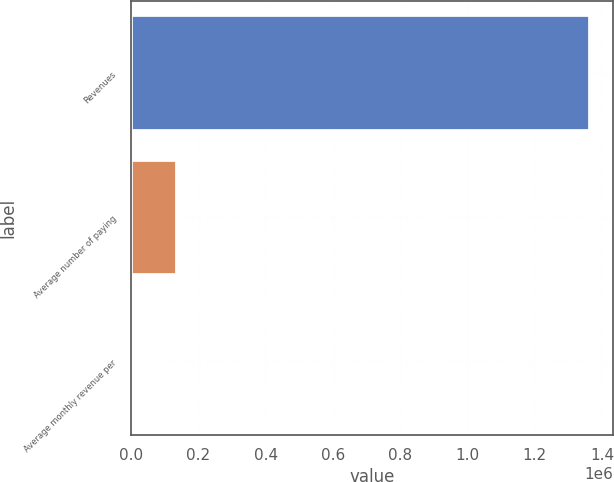Convert chart. <chart><loc_0><loc_0><loc_500><loc_500><bar_chart><fcel>Revenues<fcel>Average number of paying<fcel>Average monthly revenue per<nl><fcel>1.36466e+06<fcel>136478<fcel>13.75<nl></chart> 